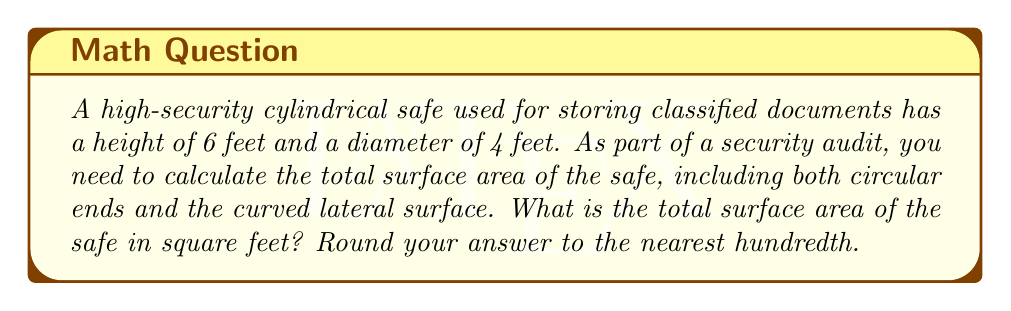Teach me how to tackle this problem. To calculate the surface area of a cylindrical safe, we need to consider three components:
1. The area of the top circular face
2. The area of the bottom circular face
3. The area of the curved lateral surface

Let's break it down step by step:

1. Area of circular faces:
   The area of a circle is given by the formula $A = \pi r^2$, where $r$ is the radius.
   Diameter = 4 feet, so radius = 2 feet
   Area of one circular face = $\pi (2)^2 = 4\pi$ sq ft
   There are two circular faces (top and bottom), so total area of circular faces = $2(4\pi) = 8\pi$ sq ft

2. Area of curved lateral surface:
   The formula for the lateral surface area of a cylinder is $A = 2\pi rh$, where $r$ is the radius and $h$ is the height.
   Radius = 2 feet, height = 6 feet
   Lateral surface area = $2\pi (2)(6) = 24\pi$ sq ft

3. Total surface area:
   Sum of the areas of circular faces and lateral surface
   Total surface area = $8\pi + 24\pi = 32\pi$ sq ft

4. Converting to numerical value and rounding:
   $32\pi \approx 100.53$ sq ft

Therefore, the total surface area of the safe is approximately 100.53 square feet.
Answer: 100.53 square feet 